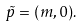<formula> <loc_0><loc_0><loc_500><loc_500>\tilde { p } = ( m , { 0 } ) .</formula> 